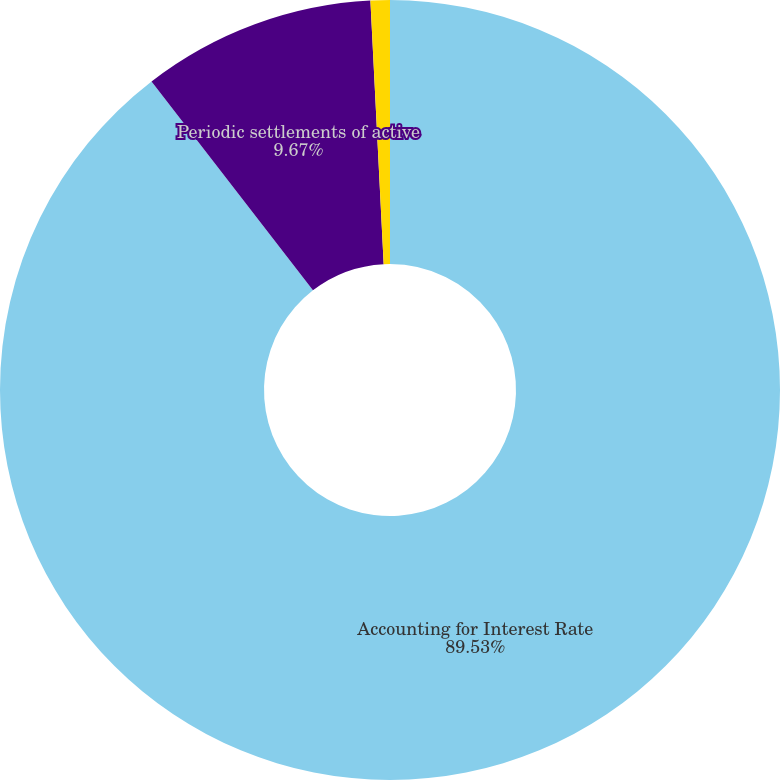Convert chart. <chart><loc_0><loc_0><loc_500><loc_500><pie_chart><fcel>Accounting for Interest Rate<fcel>Periodic settlements of active<fcel>Terminated swap agreements(b)<nl><fcel>89.52%<fcel>9.67%<fcel>0.8%<nl></chart> 